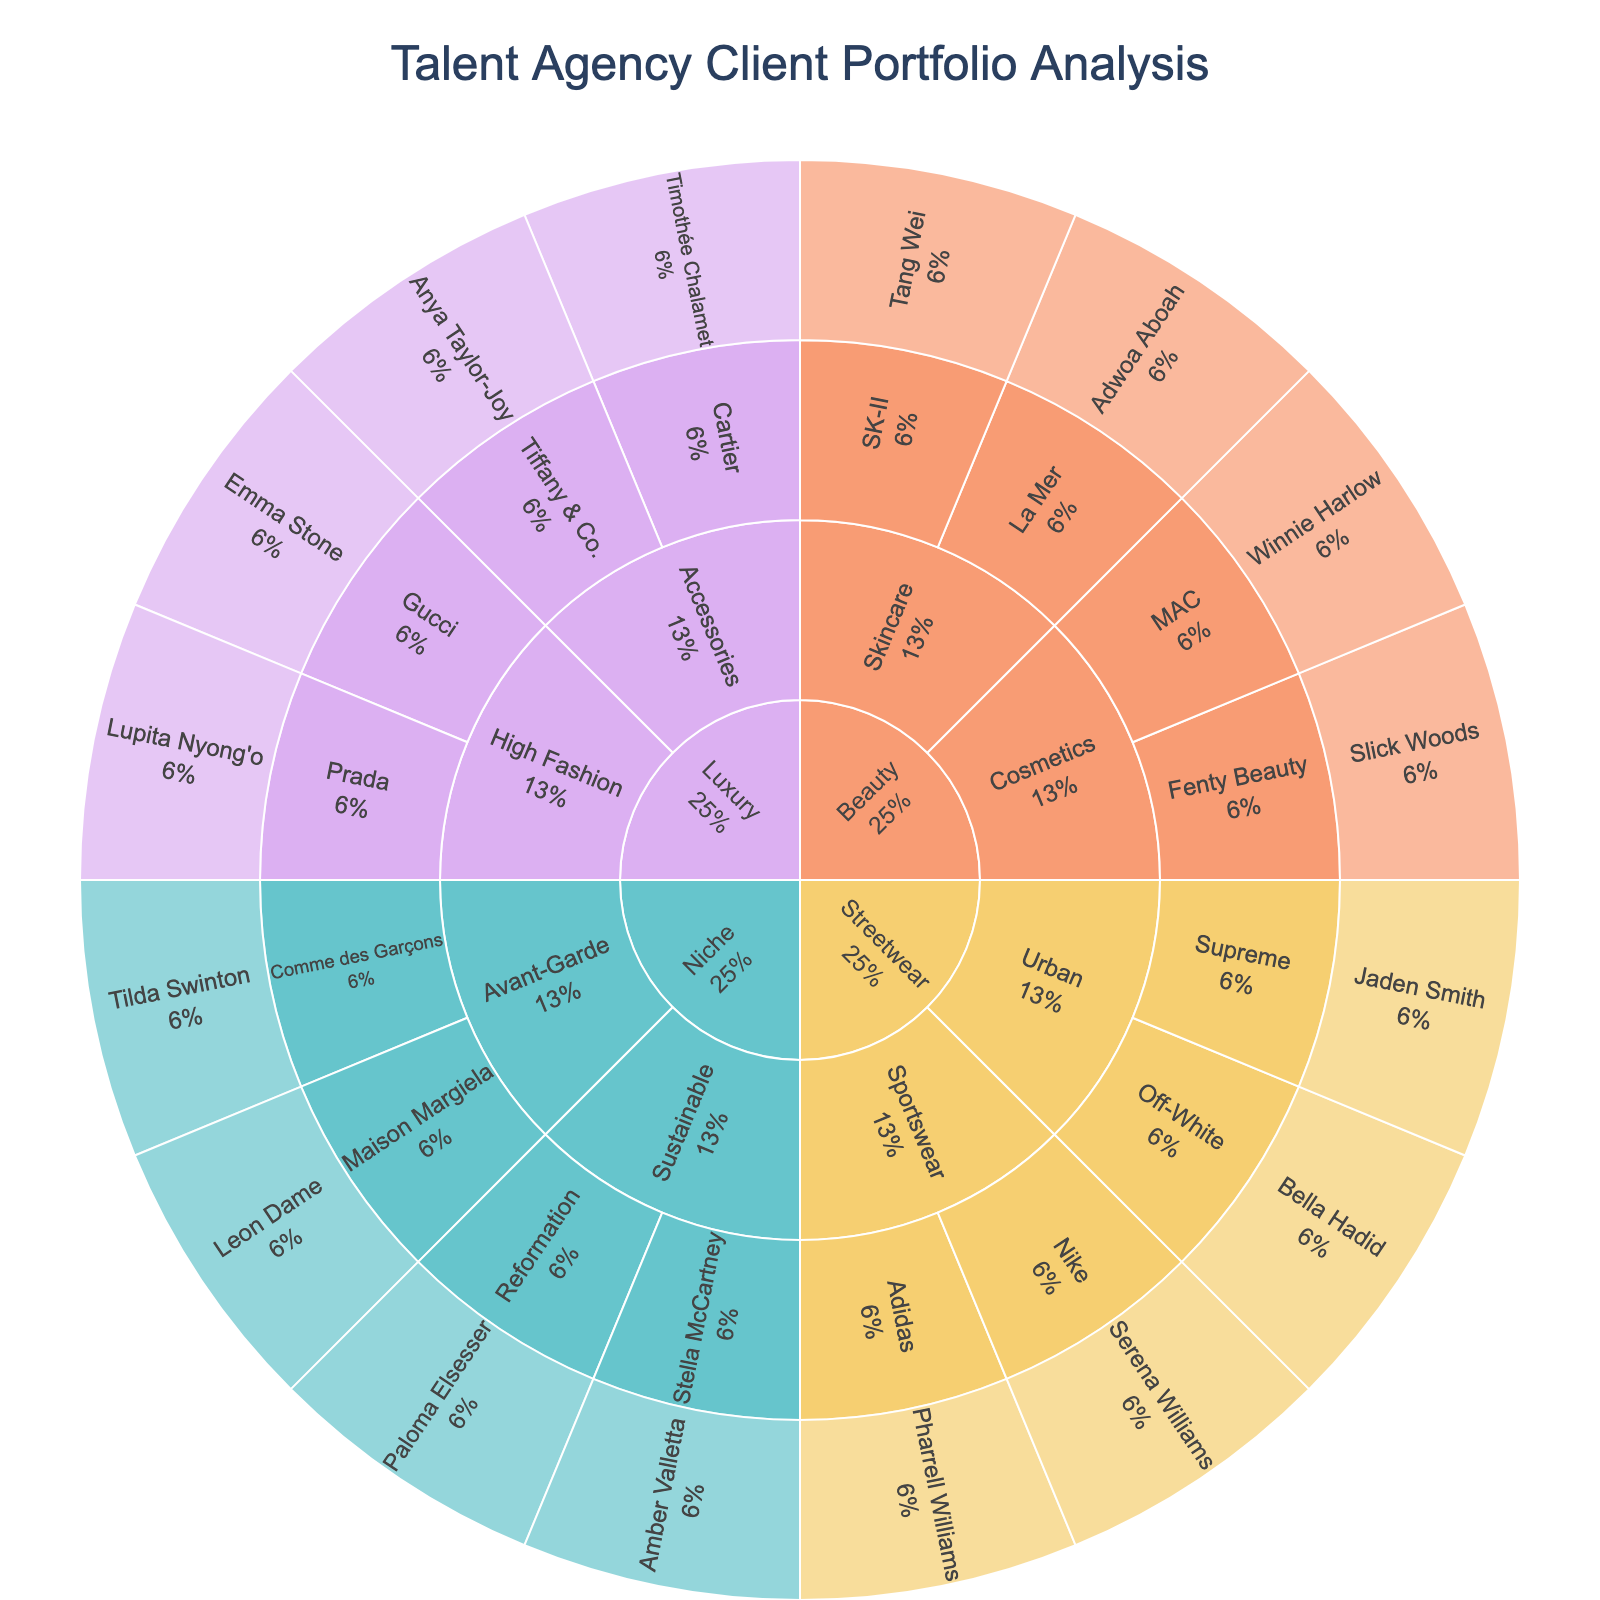What's the title of the Sunburst Plot? The title is usually positioned centrally at the top of the plot. Here, it clearly states the purpose of the visualization.
Answer: Talent Agency Client Portfolio Analysis Which category has the most subcategories? By looking at the outer layers radiating from the central category sections, we can see which one has more subdivisions.
Answer: Streetwear How many brands are there in the 'Luxury' category? Identify the 'Luxury' section, then count the immediate outer segments representing the brands. In this case, 'Luxury' has 'Gucci', 'Prada', 'Cartier', and 'Tiffany & Co.'.
Answer: 4 Which model represents the brand 'Comme des Garçons'? Locate the 'Comme des Garçons' brand segment in the 'Niche' category, and read the next layer outward for the model associated with it.
Answer: Tilda Swinton Which subcategory in 'Beauty' has more brands, 'Cosmetics' or 'Skincare'? In the 'Beauty' category, compare the 'Cosmetics' and 'Skincare' subcategories by counting the brands under each. 'Cosmetics' has 'Fenty Beauty' and 'MAC', while 'Skincare' has 'La Mer' and 'SK-II'. Both have the same number of brands.
Answer: Equal Which subcategory does Jaden Smith belong to? Locate Jaden Smith's name and trace inwards to find the corresponding subcategory. Jaden is linked to 'Supreme', which is under 'Urban' in the 'Streetwear' category.
Answer: Urban How many models are associated with 'Niche' brands? Find all the models in the 'Niche' category: Amber Valletta, Paloma Elsesser, Tilda Swinton, and Leon Dame. Count each unique model.
Answer: 4 Which category does the brand 'Nike' belong to? Locate the 'Nike' brand and trace upwards to find the overarching category it belongs to.
Answer: Streetwear Compare the number of models in 'Streetwear' and 'Beauty' categories. Which one has more? Count all models in 'Streetwear' (Jaden Smith, Bella Hadid, Serena Williams, Pharrell Williams) and in 'Beauty' (Slick Woods, Winnie Harlow, Adwoa Aboah, Tang Wei). Both categories have 4 models.
Answer: Equal Which brands are in the 'Sustainable' subcategory? Identify the 'Sustainable' subcategory within the 'Niche' category and read the immediate outward segments to list the brands.
Answer: Stella McCartney, Reformation 